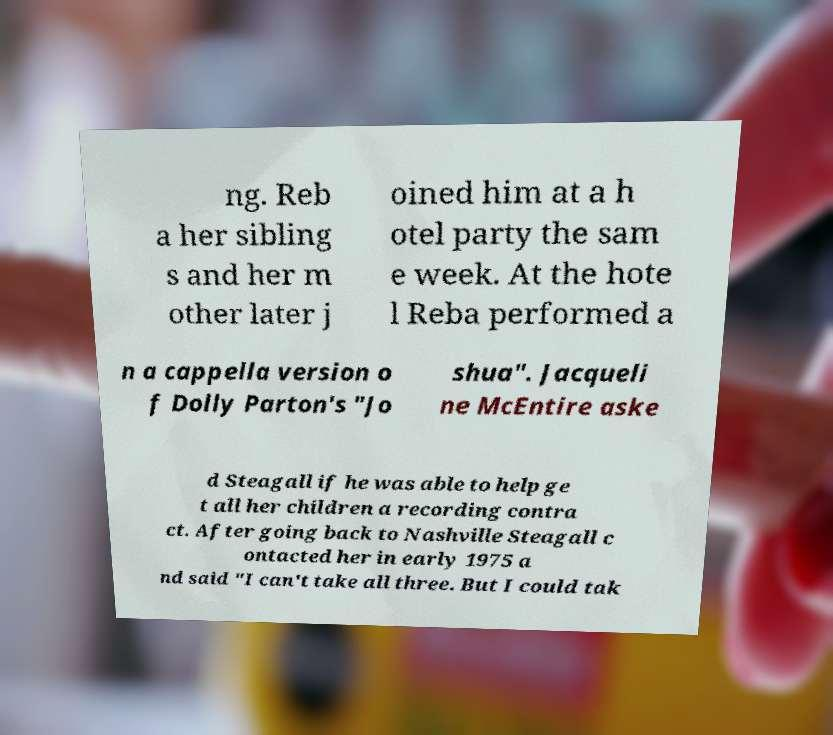Please read and relay the text visible in this image. What does it say? ng. Reb a her sibling s and her m other later j oined him at a h otel party the sam e week. At the hote l Reba performed a n a cappella version o f Dolly Parton's "Jo shua". Jacqueli ne McEntire aske d Steagall if he was able to help ge t all her children a recording contra ct. After going back to Nashville Steagall c ontacted her in early 1975 a nd said "I can't take all three. But I could tak 